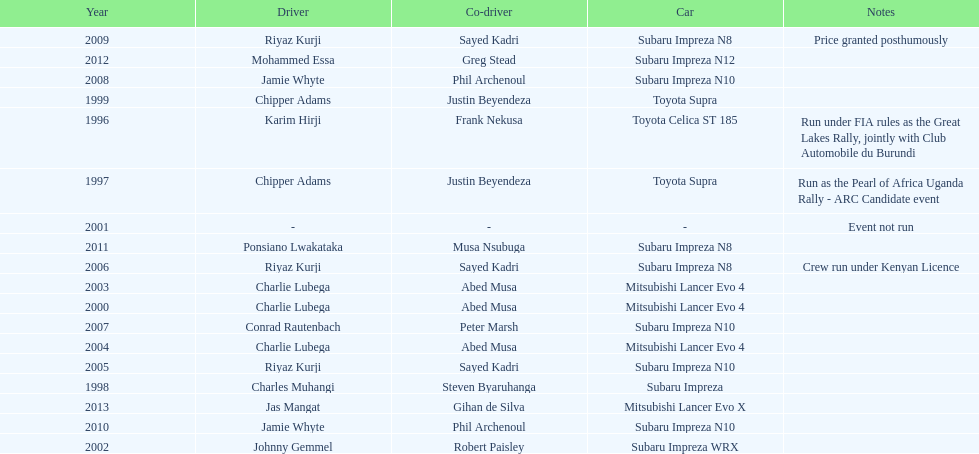Chipper adams and justin beyendeza have how mnay wins? 2. 